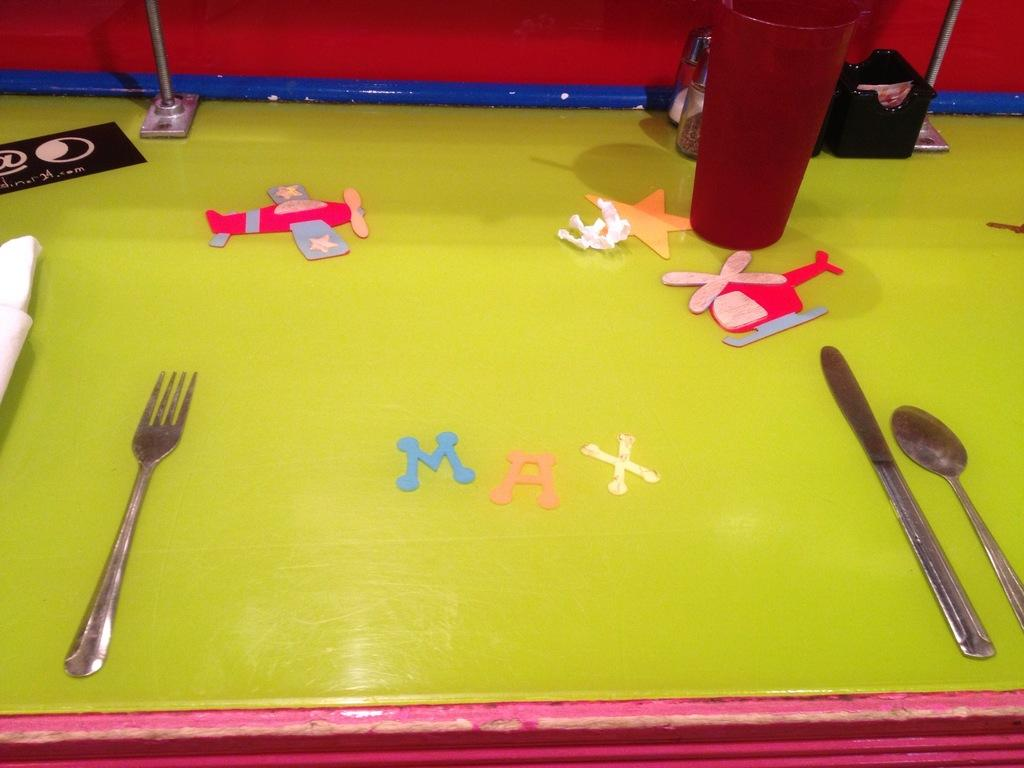What type of furniture is present in the image? There is a table in the image. What utensils can be seen on the table? There is a fork, a knife, and a spoon on the table. What type of objects are present for children's play? There are toys on the table. What is used for drinking in the image? There is a glass on the table. What is used for covering or wiping in the image? There is a cloth on the table. What other items can be seen on the table? There are other items on the table. What type of machine is used for writing in the image? There is no machine present in the image for writing; the image does not show any writing tools. 